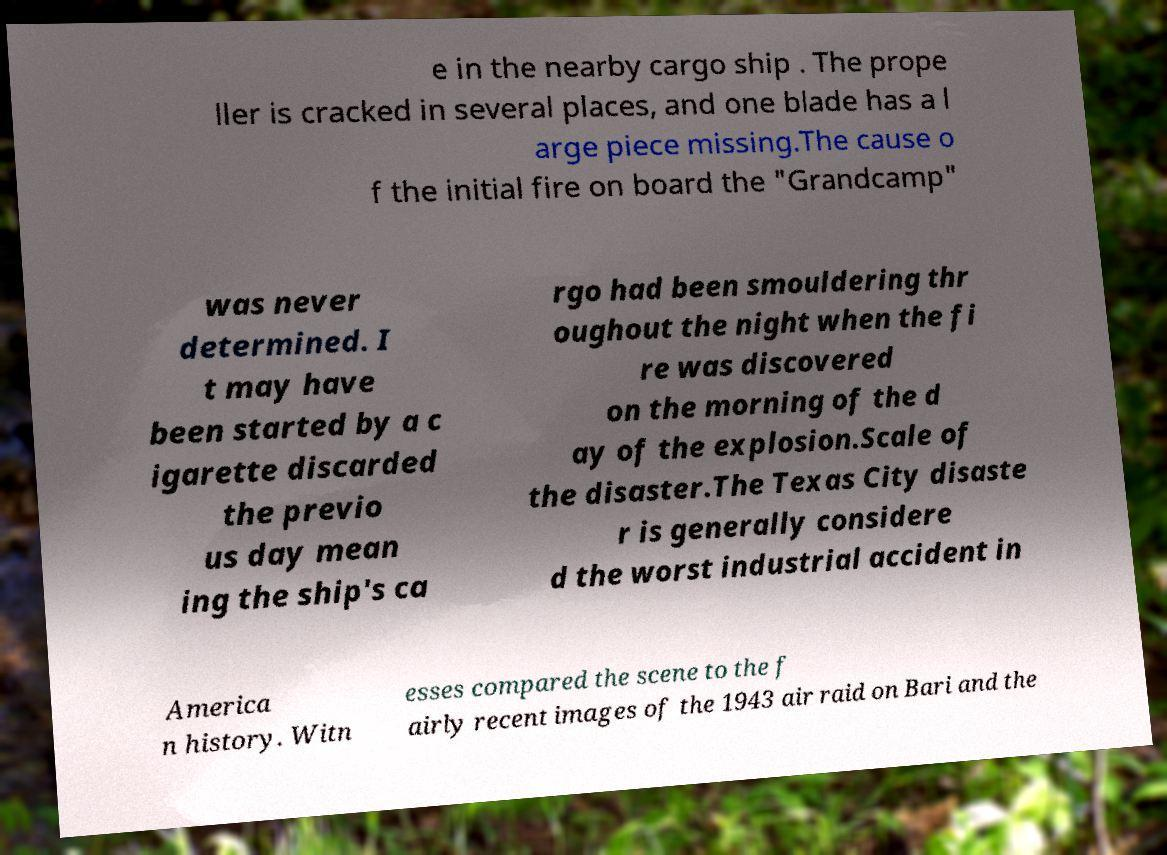Could you assist in decoding the text presented in this image and type it out clearly? e in the nearby cargo ship . The prope ller is cracked in several places, and one blade has a l arge piece missing.The cause o f the initial fire on board the "Grandcamp" was never determined. I t may have been started by a c igarette discarded the previo us day mean ing the ship's ca rgo had been smouldering thr oughout the night when the fi re was discovered on the morning of the d ay of the explosion.Scale of the disaster.The Texas City disaste r is generally considere d the worst industrial accident in America n history. Witn esses compared the scene to the f airly recent images of the 1943 air raid on Bari and the 